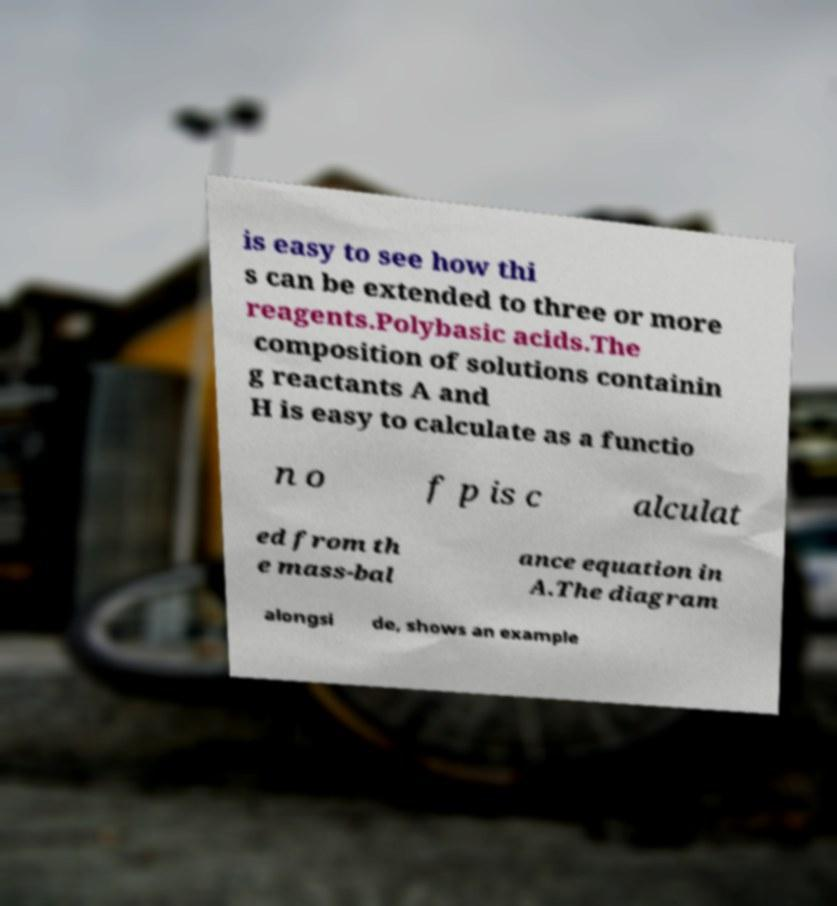Could you extract and type out the text from this image? is easy to see how thi s can be extended to three or more reagents.Polybasic acids.The composition of solutions containin g reactants A and H is easy to calculate as a functio n o f p is c alculat ed from th e mass-bal ance equation in A.The diagram alongsi de, shows an example 